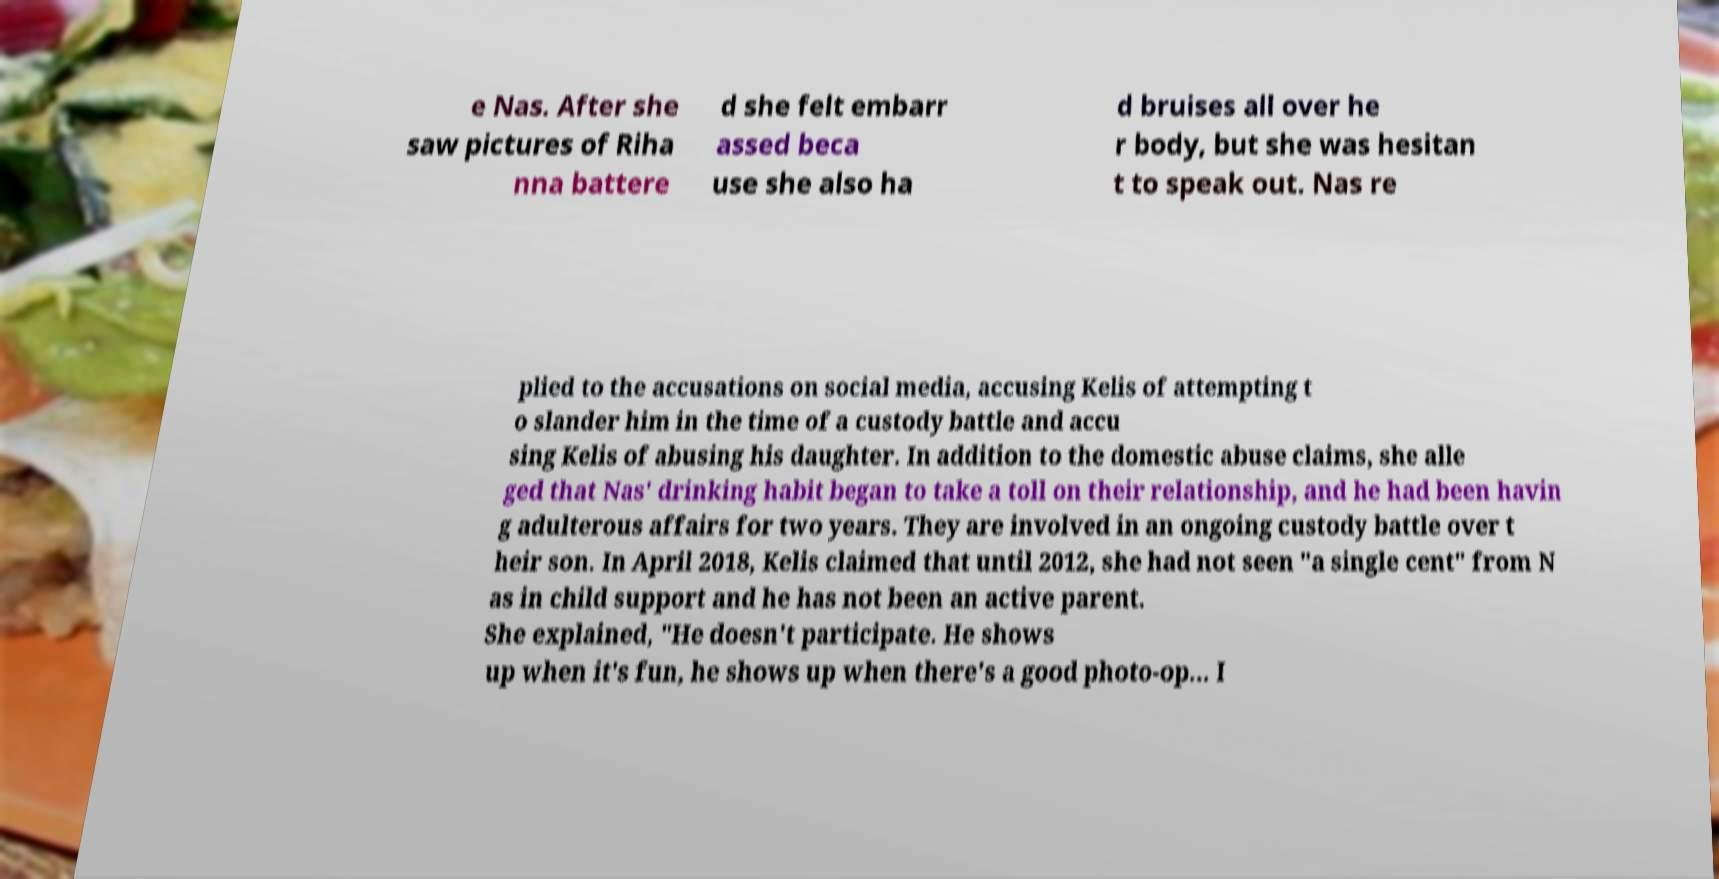I need the written content from this picture converted into text. Can you do that? e Nas. After she saw pictures of Riha nna battere d she felt embarr assed beca use she also ha d bruises all over he r body, but she was hesitan t to speak out. Nas re plied to the accusations on social media, accusing Kelis of attempting t o slander him in the time of a custody battle and accu sing Kelis of abusing his daughter. In addition to the domestic abuse claims, she alle ged that Nas' drinking habit began to take a toll on their relationship, and he had been havin g adulterous affairs for two years. They are involved in an ongoing custody battle over t heir son. In April 2018, Kelis claimed that until 2012, she had not seen "a single cent" from N as in child support and he has not been an active parent. She explained, "He doesn't participate. He shows up when it's fun, he shows up when there's a good photo-op... I 